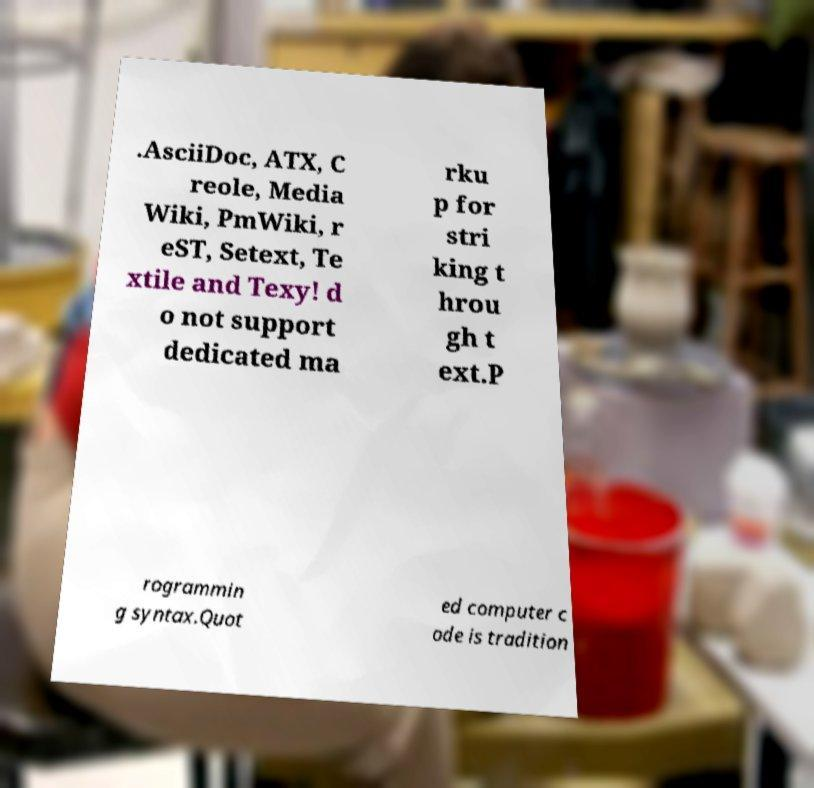For documentation purposes, I need the text within this image transcribed. Could you provide that? .AsciiDoc, ATX, C reole, Media Wiki, PmWiki, r eST, Setext, Te xtile and Texy! d o not support dedicated ma rku p for stri king t hrou gh t ext.P rogrammin g syntax.Quot ed computer c ode is tradition 